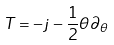Convert formula to latex. <formula><loc_0><loc_0><loc_500><loc_500>T = - j - \frac { 1 } { 2 } \theta \partial _ { \theta }</formula> 